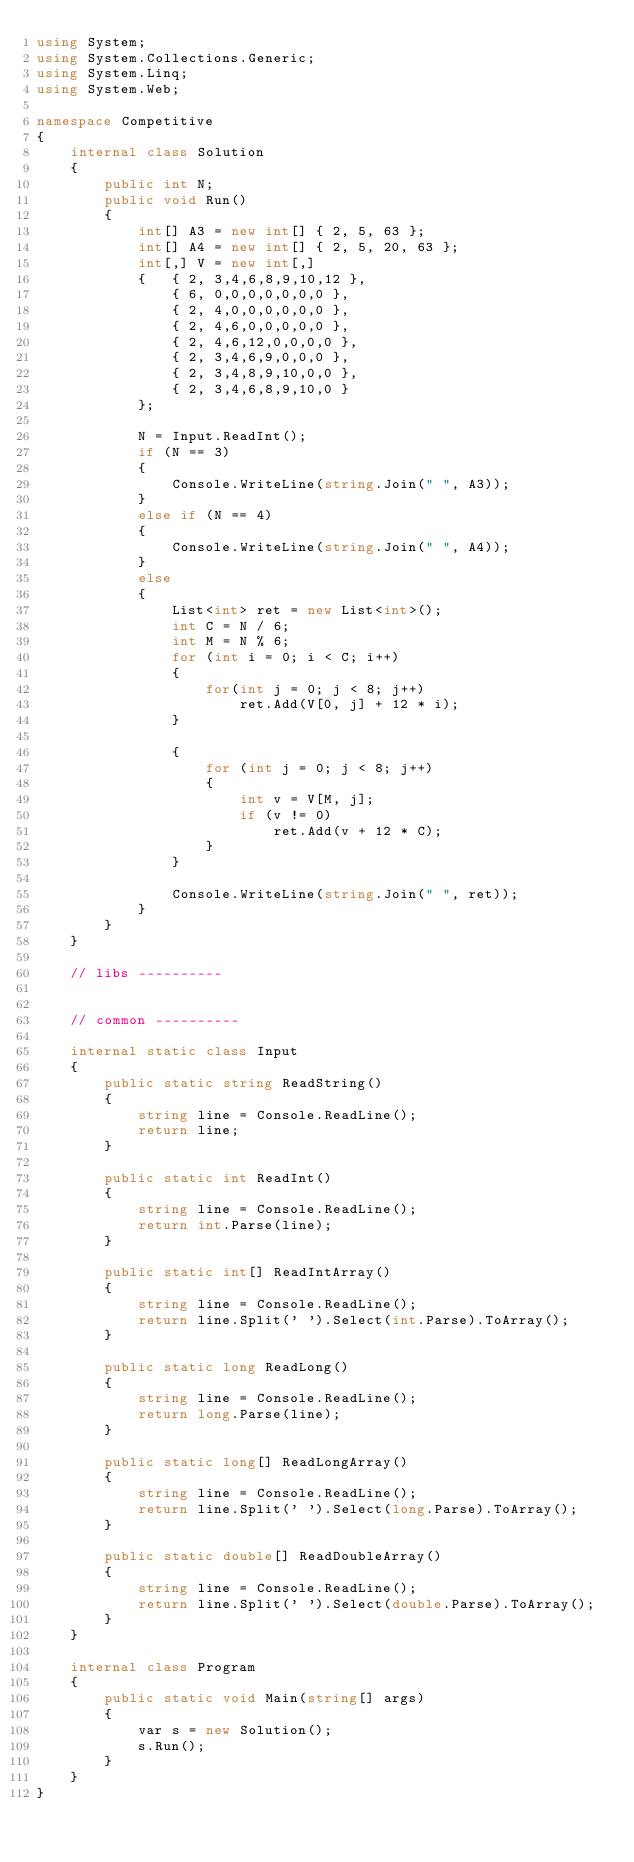<code> <loc_0><loc_0><loc_500><loc_500><_C#_>using System;
using System.Collections.Generic;
using System.Linq;
using System.Web;

namespace Competitive
{
    internal class Solution
    {
        public int N;
        public void Run()
        {
            int[] A3 = new int[] { 2, 5, 63 };
            int[] A4 = new int[] { 2, 5, 20, 63 };
            int[,] V = new int[,]
            {   { 2, 3,4,6,8,9,10,12 },
                { 6, 0,0,0,0,0,0,0 },
                { 2, 4,0,0,0,0,0,0 },
                { 2, 4,6,0,0,0,0,0 },
                { 2, 4,6,12,0,0,0,0 },
                { 2, 3,4,6,9,0,0,0 },
                { 2, 3,4,8,9,10,0,0 },
                { 2, 3,4,6,8,9,10,0 }
            };

            N = Input.ReadInt();
            if (N == 3)
            {
                Console.WriteLine(string.Join(" ", A3));
            }
            else if (N == 4)
            {
                Console.WriteLine(string.Join(" ", A4));
            }
            else
            {
                List<int> ret = new List<int>();
                int C = N / 6;
                int M = N % 6;
                for (int i = 0; i < C; i++)
                {
                    for(int j = 0; j < 8; j++)
                        ret.Add(V[0, j] + 12 * i);
                }

                {
                    for (int j = 0; j < 8; j++)
                    {
                        int v = V[M, j];
                        if (v != 0)
                            ret.Add(v + 12 * C);
                    }
                }

                Console.WriteLine(string.Join(" ", ret));   
            }
        }
    }

    // libs ----------


    // common ----------

    internal static class Input
    {
        public static string ReadString()
        {
            string line = Console.ReadLine();
            return line;
        }

        public static int ReadInt()
        {
            string line = Console.ReadLine();
            return int.Parse(line);
        }

        public static int[] ReadIntArray()
        {
            string line = Console.ReadLine();
            return line.Split(' ').Select(int.Parse).ToArray();
        }

        public static long ReadLong()
        {
            string line = Console.ReadLine();
            return long.Parse(line);
        }

        public static long[] ReadLongArray()
        {
            string line = Console.ReadLine();
            return line.Split(' ').Select(long.Parse).ToArray();
        }

        public static double[] ReadDoubleArray()
        {
            string line = Console.ReadLine();
            return line.Split(' ').Select(double.Parse).ToArray();
        }
    }

    internal class Program
    {
        public static void Main(string[] args)
        {
            var s = new Solution();
            s.Run();
        }
    }
}</code> 